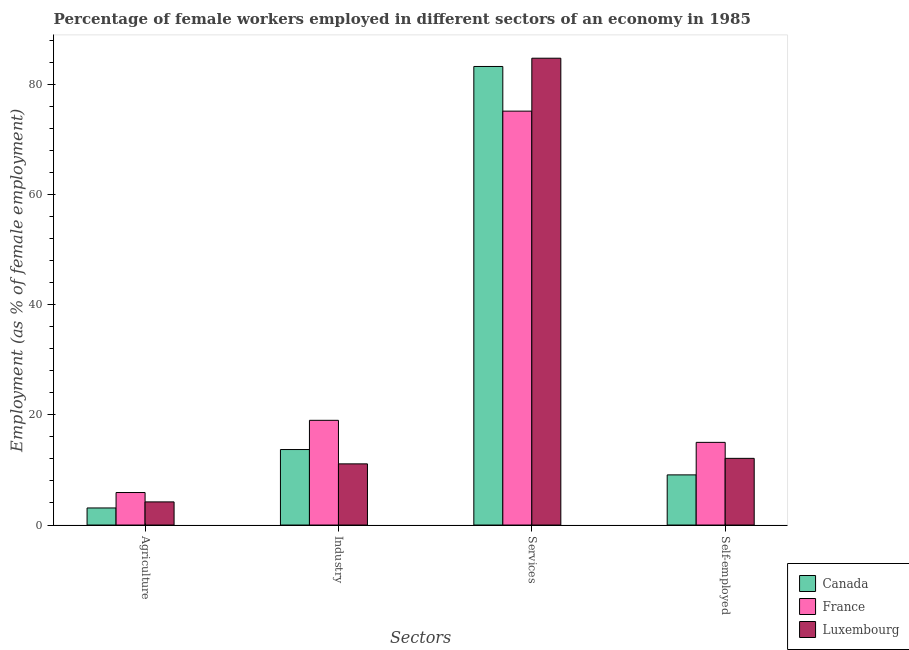How many different coloured bars are there?
Give a very brief answer. 3. Are the number of bars on each tick of the X-axis equal?
Ensure brevity in your answer.  Yes. How many bars are there on the 1st tick from the right?
Offer a terse response. 3. What is the label of the 2nd group of bars from the left?
Make the answer very short. Industry. What is the percentage of self employed female workers in France?
Offer a very short reply. 15. Across all countries, what is the maximum percentage of self employed female workers?
Provide a short and direct response. 15. Across all countries, what is the minimum percentage of female workers in services?
Your response must be concise. 75.1. In which country was the percentage of female workers in services maximum?
Offer a terse response. Luxembourg. In which country was the percentage of female workers in services minimum?
Offer a very short reply. France. What is the total percentage of female workers in agriculture in the graph?
Keep it short and to the point. 13.2. What is the difference between the percentage of female workers in industry in Canada and that in France?
Give a very brief answer. -5.3. What is the difference between the percentage of female workers in services in France and the percentage of self employed female workers in Luxembourg?
Your answer should be very brief. 63. What is the average percentage of female workers in industry per country?
Provide a succinct answer. 14.6. What is the difference between the percentage of female workers in agriculture and percentage of female workers in services in Canada?
Offer a terse response. -80.1. What is the ratio of the percentage of self employed female workers in France to that in Canada?
Make the answer very short. 1.65. Is the percentage of self employed female workers in Luxembourg less than that in Canada?
Provide a short and direct response. No. What is the difference between the highest and the lowest percentage of self employed female workers?
Offer a very short reply. 5.9. In how many countries, is the percentage of self employed female workers greater than the average percentage of self employed female workers taken over all countries?
Give a very brief answer. 2. Is it the case that in every country, the sum of the percentage of female workers in industry and percentage of female workers in agriculture is greater than the sum of percentage of self employed female workers and percentage of female workers in services?
Make the answer very short. No. What does the 3rd bar from the left in Self-employed represents?
Keep it short and to the point. Luxembourg. What does the 1st bar from the right in Services represents?
Give a very brief answer. Luxembourg. Is it the case that in every country, the sum of the percentage of female workers in agriculture and percentage of female workers in industry is greater than the percentage of female workers in services?
Your answer should be very brief. No. How many bars are there?
Keep it short and to the point. 12. Are all the bars in the graph horizontal?
Provide a succinct answer. No. What is the difference between two consecutive major ticks on the Y-axis?
Give a very brief answer. 20. Does the graph contain grids?
Your answer should be compact. No. Where does the legend appear in the graph?
Ensure brevity in your answer.  Bottom right. What is the title of the graph?
Your answer should be very brief. Percentage of female workers employed in different sectors of an economy in 1985. Does "Kosovo" appear as one of the legend labels in the graph?
Your answer should be very brief. No. What is the label or title of the X-axis?
Make the answer very short. Sectors. What is the label or title of the Y-axis?
Your answer should be compact. Employment (as % of female employment). What is the Employment (as % of female employment) in Canada in Agriculture?
Offer a terse response. 3.1. What is the Employment (as % of female employment) of France in Agriculture?
Your answer should be very brief. 5.9. What is the Employment (as % of female employment) of Luxembourg in Agriculture?
Your response must be concise. 4.2. What is the Employment (as % of female employment) of Canada in Industry?
Provide a short and direct response. 13.7. What is the Employment (as % of female employment) of Luxembourg in Industry?
Ensure brevity in your answer.  11.1. What is the Employment (as % of female employment) in Canada in Services?
Your answer should be very brief. 83.2. What is the Employment (as % of female employment) in France in Services?
Provide a succinct answer. 75.1. What is the Employment (as % of female employment) of Luxembourg in Services?
Your answer should be compact. 84.7. What is the Employment (as % of female employment) in Canada in Self-employed?
Make the answer very short. 9.1. What is the Employment (as % of female employment) in Luxembourg in Self-employed?
Provide a short and direct response. 12.1. Across all Sectors, what is the maximum Employment (as % of female employment) of Canada?
Provide a succinct answer. 83.2. Across all Sectors, what is the maximum Employment (as % of female employment) of France?
Your response must be concise. 75.1. Across all Sectors, what is the maximum Employment (as % of female employment) in Luxembourg?
Ensure brevity in your answer.  84.7. Across all Sectors, what is the minimum Employment (as % of female employment) in Canada?
Ensure brevity in your answer.  3.1. Across all Sectors, what is the minimum Employment (as % of female employment) of France?
Your response must be concise. 5.9. Across all Sectors, what is the minimum Employment (as % of female employment) of Luxembourg?
Your response must be concise. 4.2. What is the total Employment (as % of female employment) in Canada in the graph?
Provide a succinct answer. 109.1. What is the total Employment (as % of female employment) of France in the graph?
Offer a terse response. 115. What is the total Employment (as % of female employment) in Luxembourg in the graph?
Your response must be concise. 112.1. What is the difference between the Employment (as % of female employment) of Luxembourg in Agriculture and that in Industry?
Offer a very short reply. -6.9. What is the difference between the Employment (as % of female employment) in Canada in Agriculture and that in Services?
Give a very brief answer. -80.1. What is the difference between the Employment (as % of female employment) in France in Agriculture and that in Services?
Provide a short and direct response. -69.2. What is the difference between the Employment (as % of female employment) of Luxembourg in Agriculture and that in Services?
Provide a short and direct response. -80.5. What is the difference between the Employment (as % of female employment) in France in Agriculture and that in Self-employed?
Provide a succinct answer. -9.1. What is the difference between the Employment (as % of female employment) of Luxembourg in Agriculture and that in Self-employed?
Your response must be concise. -7.9. What is the difference between the Employment (as % of female employment) of Canada in Industry and that in Services?
Your response must be concise. -69.5. What is the difference between the Employment (as % of female employment) in France in Industry and that in Services?
Ensure brevity in your answer.  -56.1. What is the difference between the Employment (as % of female employment) of Luxembourg in Industry and that in Services?
Ensure brevity in your answer.  -73.6. What is the difference between the Employment (as % of female employment) in Canada in Industry and that in Self-employed?
Offer a terse response. 4.6. What is the difference between the Employment (as % of female employment) of Canada in Services and that in Self-employed?
Provide a short and direct response. 74.1. What is the difference between the Employment (as % of female employment) in France in Services and that in Self-employed?
Offer a very short reply. 60.1. What is the difference between the Employment (as % of female employment) in Luxembourg in Services and that in Self-employed?
Give a very brief answer. 72.6. What is the difference between the Employment (as % of female employment) of Canada in Agriculture and the Employment (as % of female employment) of France in Industry?
Give a very brief answer. -15.9. What is the difference between the Employment (as % of female employment) in France in Agriculture and the Employment (as % of female employment) in Luxembourg in Industry?
Ensure brevity in your answer.  -5.2. What is the difference between the Employment (as % of female employment) in Canada in Agriculture and the Employment (as % of female employment) in France in Services?
Keep it short and to the point. -72. What is the difference between the Employment (as % of female employment) in Canada in Agriculture and the Employment (as % of female employment) in Luxembourg in Services?
Provide a short and direct response. -81.6. What is the difference between the Employment (as % of female employment) in France in Agriculture and the Employment (as % of female employment) in Luxembourg in Services?
Your answer should be compact. -78.8. What is the difference between the Employment (as % of female employment) of Canada in Agriculture and the Employment (as % of female employment) of France in Self-employed?
Your answer should be very brief. -11.9. What is the difference between the Employment (as % of female employment) of Canada in Agriculture and the Employment (as % of female employment) of Luxembourg in Self-employed?
Ensure brevity in your answer.  -9. What is the difference between the Employment (as % of female employment) of Canada in Industry and the Employment (as % of female employment) of France in Services?
Provide a succinct answer. -61.4. What is the difference between the Employment (as % of female employment) in Canada in Industry and the Employment (as % of female employment) in Luxembourg in Services?
Offer a terse response. -71. What is the difference between the Employment (as % of female employment) of France in Industry and the Employment (as % of female employment) of Luxembourg in Services?
Provide a short and direct response. -65.7. What is the difference between the Employment (as % of female employment) in Canada in Industry and the Employment (as % of female employment) in France in Self-employed?
Give a very brief answer. -1.3. What is the difference between the Employment (as % of female employment) in Canada in Services and the Employment (as % of female employment) in France in Self-employed?
Your answer should be compact. 68.2. What is the difference between the Employment (as % of female employment) in Canada in Services and the Employment (as % of female employment) in Luxembourg in Self-employed?
Offer a very short reply. 71.1. What is the average Employment (as % of female employment) of Canada per Sectors?
Give a very brief answer. 27.27. What is the average Employment (as % of female employment) of France per Sectors?
Ensure brevity in your answer.  28.75. What is the average Employment (as % of female employment) of Luxembourg per Sectors?
Provide a succinct answer. 28.02. What is the difference between the Employment (as % of female employment) in Canada and Employment (as % of female employment) in France in Agriculture?
Give a very brief answer. -2.8. What is the difference between the Employment (as % of female employment) of France and Employment (as % of female employment) of Luxembourg in Agriculture?
Offer a terse response. 1.7. What is the difference between the Employment (as % of female employment) in Canada and Employment (as % of female employment) in Luxembourg in Industry?
Offer a very short reply. 2.6. What is the difference between the Employment (as % of female employment) in France and Employment (as % of female employment) in Luxembourg in Industry?
Offer a terse response. 7.9. What is the difference between the Employment (as % of female employment) in Canada and Employment (as % of female employment) in Luxembourg in Services?
Ensure brevity in your answer.  -1.5. What is the difference between the Employment (as % of female employment) of Canada and Employment (as % of female employment) of Luxembourg in Self-employed?
Ensure brevity in your answer.  -3. What is the ratio of the Employment (as % of female employment) of Canada in Agriculture to that in Industry?
Give a very brief answer. 0.23. What is the ratio of the Employment (as % of female employment) in France in Agriculture to that in Industry?
Keep it short and to the point. 0.31. What is the ratio of the Employment (as % of female employment) in Luxembourg in Agriculture to that in Industry?
Your answer should be compact. 0.38. What is the ratio of the Employment (as % of female employment) of Canada in Agriculture to that in Services?
Keep it short and to the point. 0.04. What is the ratio of the Employment (as % of female employment) of France in Agriculture to that in Services?
Offer a terse response. 0.08. What is the ratio of the Employment (as % of female employment) in Luxembourg in Agriculture to that in Services?
Your response must be concise. 0.05. What is the ratio of the Employment (as % of female employment) of Canada in Agriculture to that in Self-employed?
Ensure brevity in your answer.  0.34. What is the ratio of the Employment (as % of female employment) in France in Agriculture to that in Self-employed?
Your answer should be very brief. 0.39. What is the ratio of the Employment (as % of female employment) of Luxembourg in Agriculture to that in Self-employed?
Provide a short and direct response. 0.35. What is the ratio of the Employment (as % of female employment) of Canada in Industry to that in Services?
Your response must be concise. 0.16. What is the ratio of the Employment (as % of female employment) in France in Industry to that in Services?
Make the answer very short. 0.25. What is the ratio of the Employment (as % of female employment) of Luxembourg in Industry to that in Services?
Provide a short and direct response. 0.13. What is the ratio of the Employment (as % of female employment) in Canada in Industry to that in Self-employed?
Your answer should be compact. 1.51. What is the ratio of the Employment (as % of female employment) in France in Industry to that in Self-employed?
Offer a very short reply. 1.27. What is the ratio of the Employment (as % of female employment) in Luxembourg in Industry to that in Self-employed?
Offer a terse response. 0.92. What is the ratio of the Employment (as % of female employment) of Canada in Services to that in Self-employed?
Your response must be concise. 9.14. What is the ratio of the Employment (as % of female employment) in France in Services to that in Self-employed?
Provide a short and direct response. 5.01. What is the difference between the highest and the second highest Employment (as % of female employment) of Canada?
Make the answer very short. 69.5. What is the difference between the highest and the second highest Employment (as % of female employment) of France?
Give a very brief answer. 56.1. What is the difference between the highest and the second highest Employment (as % of female employment) in Luxembourg?
Offer a very short reply. 72.6. What is the difference between the highest and the lowest Employment (as % of female employment) in Canada?
Give a very brief answer. 80.1. What is the difference between the highest and the lowest Employment (as % of female employment) in France?
Provide a succinct answer. 69.2. What is the difference between the highest and the lowest Employment (as % of female employment) of Luxembourg?
Keep it short and to the point. 80.5. 